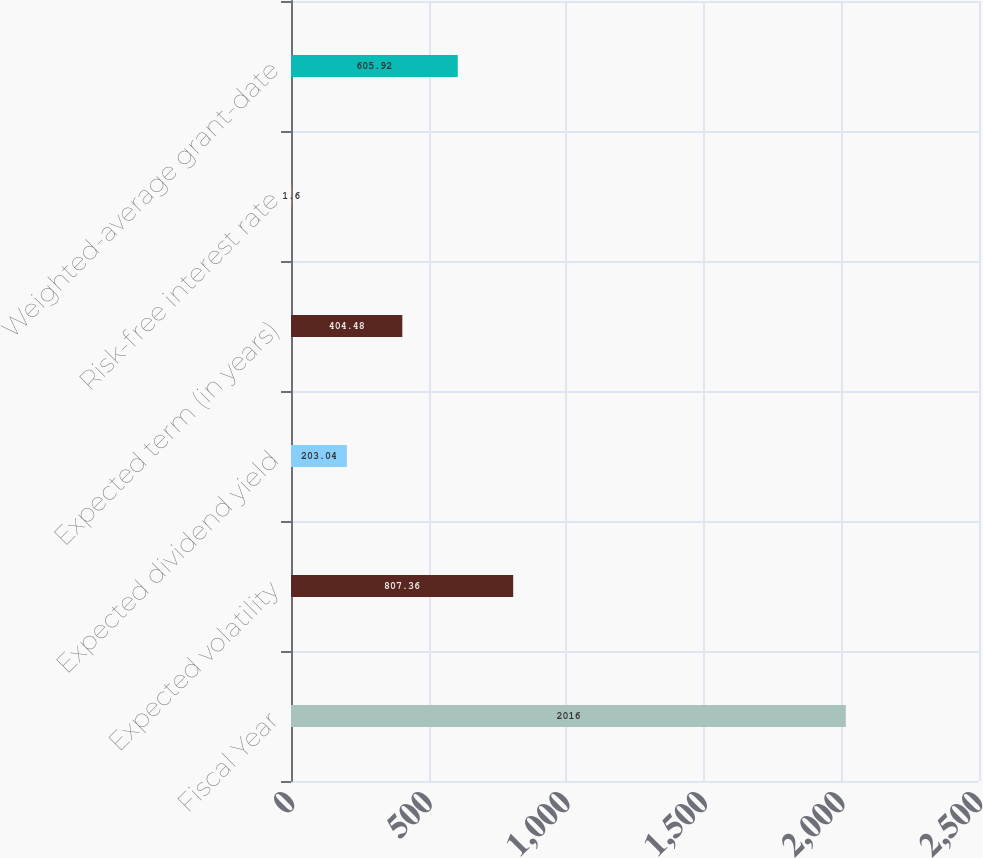<chart> <loc_0><loc_0><loc_500><loc_500><bar_chart><fcel>Fiscal Year<fcel>Expected volatility<fcel>Expected dividend yield<fcel>Expected term (in years)<fcel>Risk-free interest rate<fcel>Weighted-average grant-date<nl><fcel>2016<fcel>807.36<fcel>203.04<fcel>404.48<fcel>1.6<fcel>605.92<nl></chart> 